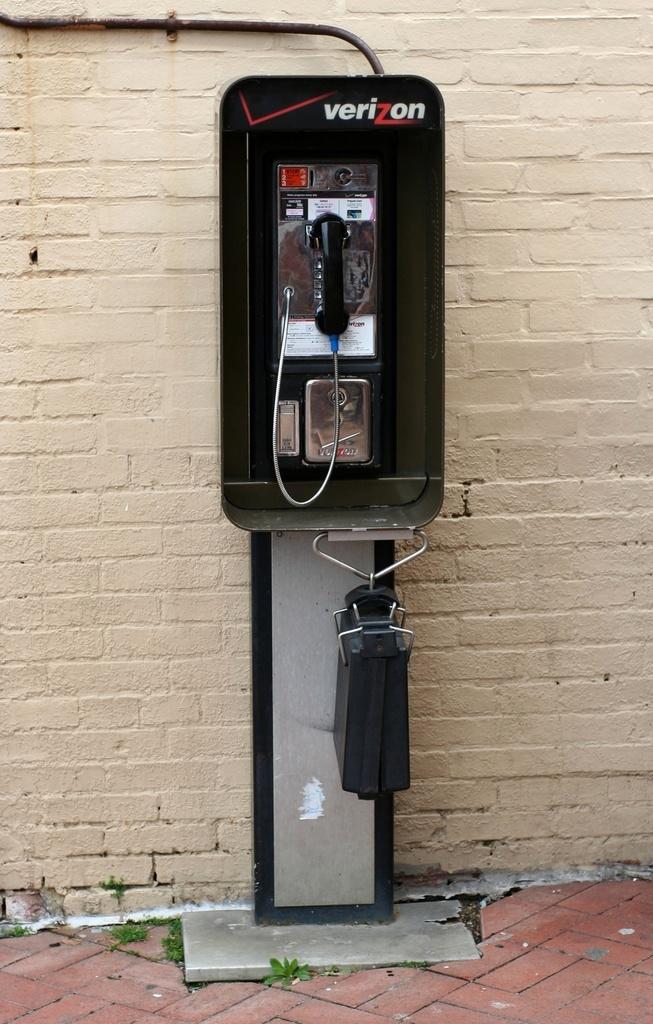Please provide a concise description of this image. This picture is consists of a verizon telephone booth in the center of the image. 